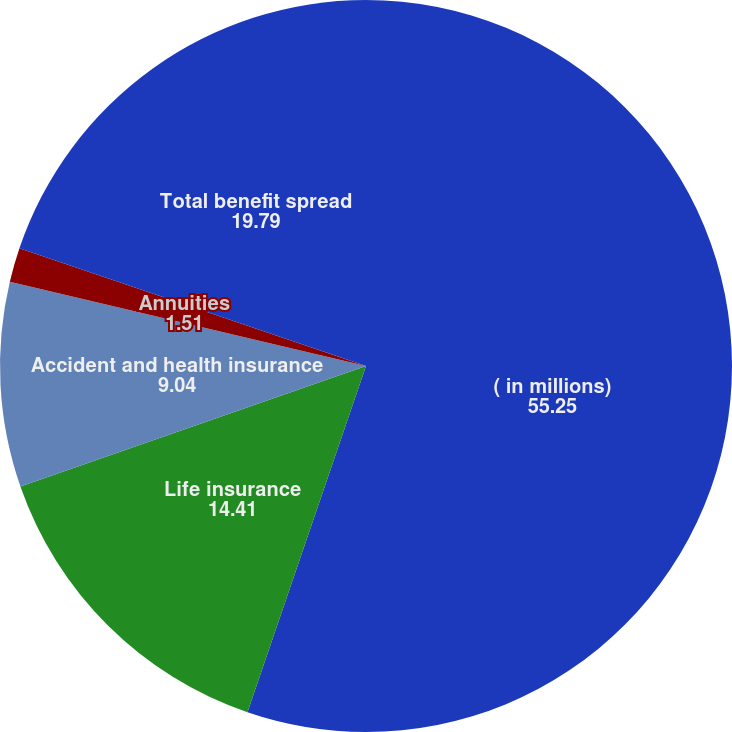Convert chart. <chart><loc_0><loc_0><loc_500><loc_500><pie_chart><fcel>( in millions)<fcel>Life insurance<fcel>Accident and health insurance<fcel>Annuities<fcel>Total benefit spread<nl><fcel>55.25%<fcel>14.41%<fcel>9.04%<fcel>1.51%<fcel>19.79%<nl></chart> 